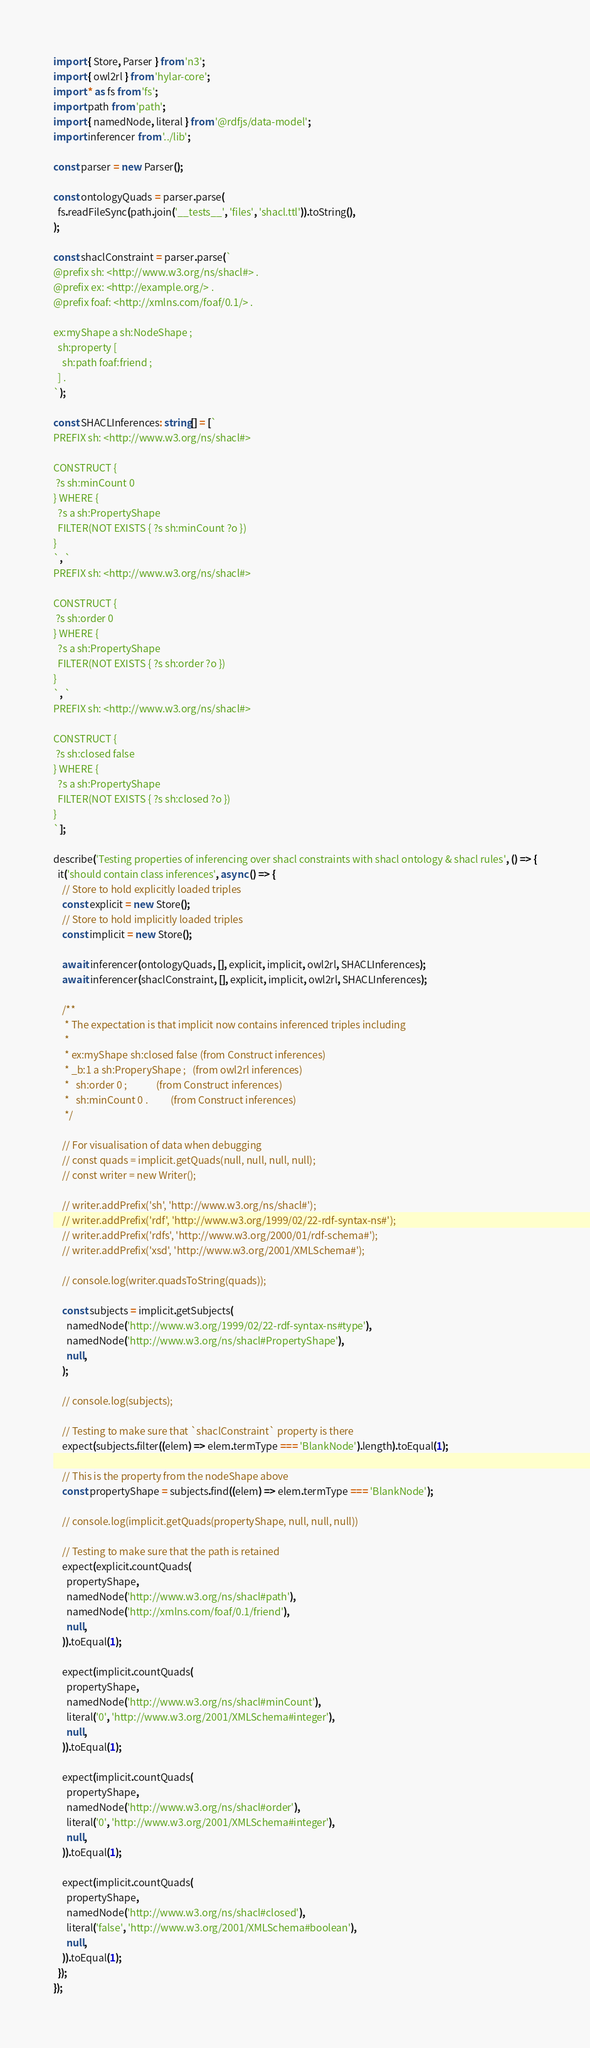<code> <loc_0><loc_0><loc_500><loc_500><_TypeScript_>import { Store, Parser } from 'n3';
import { owl2rl } from 'hylar-core';
import * as fs from 'fs';
import path from 'path';
import { namedNode, literal } from '@rdfjs/data-model';
import inferencer from '../lib';

const parser = new Parser();

const ontologyQuads = parser.parse(
  fs.readFileSync(path.join('__tests__', 'files', 'shacl.ttl')).toString(),
);

const shaclConstraint = parser.parse(`
@prefix sh: <http://www.w3.org/ns/shacl#> .
@prefix ex: <http://example.org/> .
@prefix foaf: <http://xmlns.com/foaf/0.1/> .

ex:myShape a sh:NodeShape ;
  sh:property [
    sh:path foaf:friend ;
  ] .
`);

const SHACLInferences: string[] = [`
PREFIX sh: <http://www.w3.org/ns/shacl#>

CONSTRUCT {
 ?s sh:minCount 0
} WHERE {
  ?s a sh:PropertyShape
  FILTER(NOT EXISTS { ?s sh:minCount ?o })
}
`, `
PREFIX sh: <http://www.w3.org/ns/shacl#>

CONSTRUCT {
 ?s sh:order 0
} WHERE {
  ?s a sh:PropertyShape
  FILTER(NOT EXISTS { ?s sh:order ?o })
}
`, `
PREFIX sh: <http://www.w3.org/ns/shacl#>

CONSTRUCT {
 ?s sh:closed false
} WHERE {
  ?s a sh:PropertyShape
  FILTER(NOT EXISTS { ?s sh:closed ?o })
}
`];

describe('Testing properties of inferencing over shacl constraints with shacl ontology & shacl rules', () => {
  it('should contain class inferences', async () => {
    // Store to hold explicitly loaded triples
    const explicit = new Store();
    // Store to hold implicitly loaded triples
    const implicit = new Store();

    await inferencer(ontologyQuads, [], explicit, implicit, owl2rl, SHACLInferences);
    await inferencer(shaclConstraint, [], explicit, implicit, owl2rl, SHACLInferences);

    /**
     * The expectation is that implicit now contains inferenced triples including
     *
     * ex:myShape sh:closed false (from Construct inferences)
     * _b:1 a sh:ProperyShape ;   (from owl2rl inferences)
     *   sh:order 0 ;             (from Construct inferences)
     *   sh:minCount 0 .          (from Construct inferences)
     */

    // For visualisation of data when debugging
    // const quads = implicit.getQuads(null, null, null, null);
    // const writer = new Writer();

    // writer.addPrefix('sh', 'http://www.w3.org/ns/shacl#');
    // writer.addPrefix('rdf', 'http://www.w3.org/1999/02/22-rdf-syntax-ns#');
    // writer.addPrefix('rdfs', 'http://www.w3.org/2000/01/rdf-schema#');
    // writer.addPrefix('xsd', 'http://www.w3.org/2001/XMLSchema#');

    // console.log(writer.quadsToString(quads));

    const subjects = implicit.getSubjects(
      namedNode('http://www.w3.org/1999/02/22-rdf-syntax-ns#type'),
      namedNode('http://www.w3.org/ns/shacl#PropertyShape'),
      null,
    );

    // console.log(subjects);

    // Testing to make sure that `shaclConstraint` property is there
    expect(subjects.filter((elem) => elem.termType === 'BlankNode').length).toEqual(1);

    // This is the property from the nodeShape above
    const propertyShape = subjects.find((elem) => elem.termType === 'BlankNode');

    // console.log(implicit.getQuads(propertyShape, null, null, null))

    // Testing to make sure that the path is retained
    expect(explicit.countQuads(
      propertyShape,
      namedNode('http://www.w3.org/ns/shacl#path'),
      namedNode('http://xmlns.com/foaf/0.1/friend'),
      null,
    )).toEqual(1);

    expect(implicit.countQuads(
      propertyShape,
      namedNode('http://www.w3.org/ns/shacl#minCount'),
      literal('0', 'http://www.w3.org/2001/XMLSchema#integer'),
      null,
    )).toEqual(1);

    expect(implicit.countQuads(
      propertyShape,
      namedNode('http://www.w3.org/ns/shacl#order'),
      literal('0', 'http://www.w3.org/2001/XMLSchema#integer'),
      null,
    )).toEqual(1);

    expect(implicit.countQuads(
      propertyShape,
      namedNode('http://www.w3.org/ns/shacl#closed'),
      literal('false', 'http://www.w3.org/2001/XMLSchema#boolean'),
      null,
    )).toEqual(1);
  });
});
</code> 